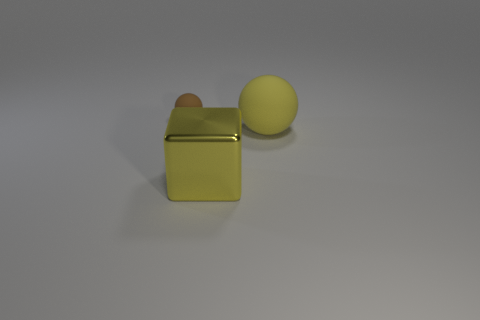Add 1 cyan cubes. How many objects exist? 4 Subtract all balls. How many objects are left? 1 Add 3 yellow metal blocks. How many yellow metal blocks are left? 4 Add 1 big objects. How many big objects exist? 3 Subtract 0 brown cylinders. How many objects are left? 3 Subtract all blue matte cubes. Subtract all large yellow cubes. How many objects are left? 2 